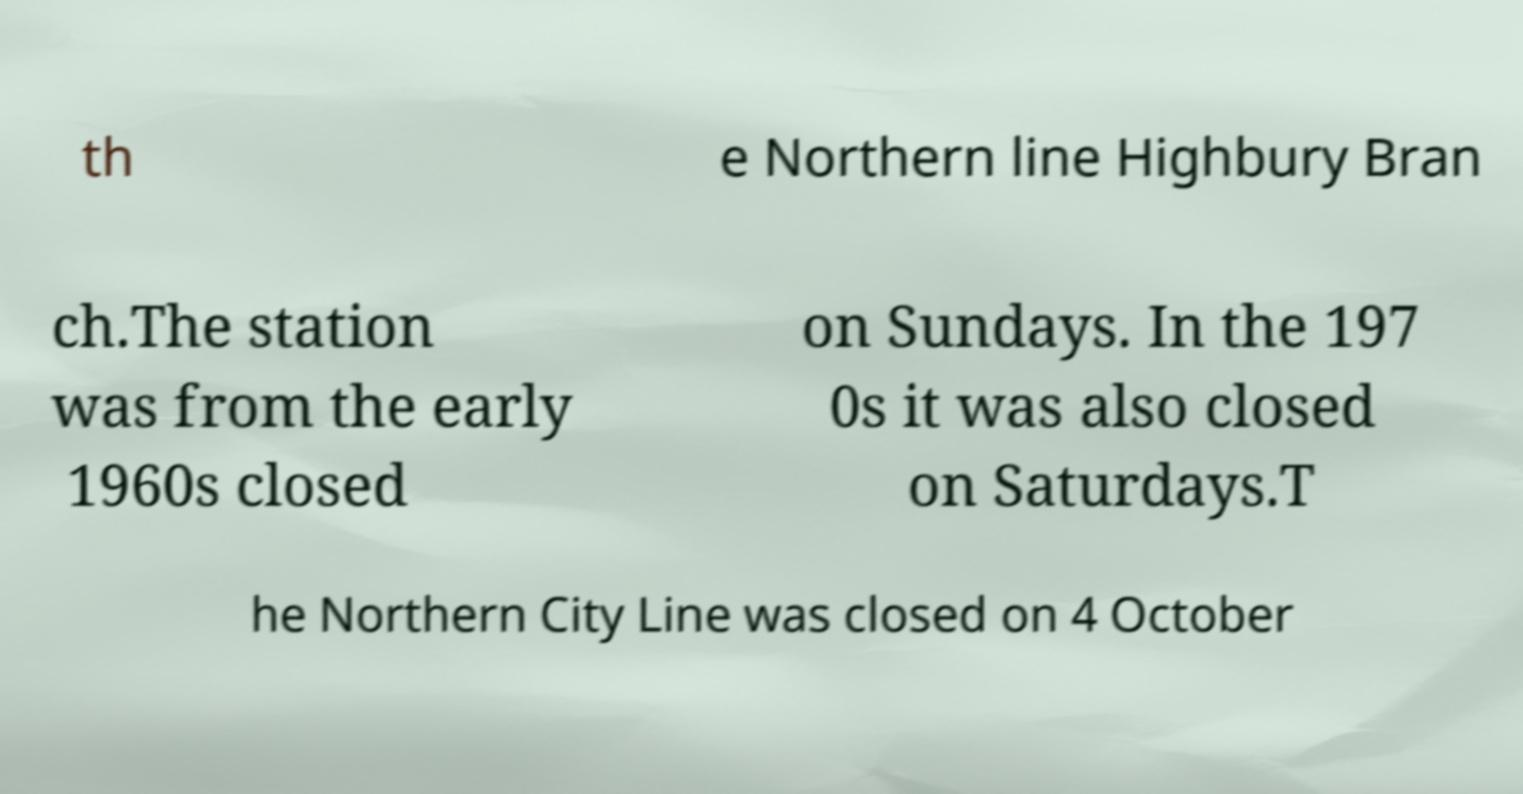Can you accurately transcribe the text from the provided image for me? th e Northern line Highbury Bran ch.The station was from the early 1960s closed on Sundays. In the 197 0s it was also closed on Saturdays.T he Northern City Line was closed on 4 October 